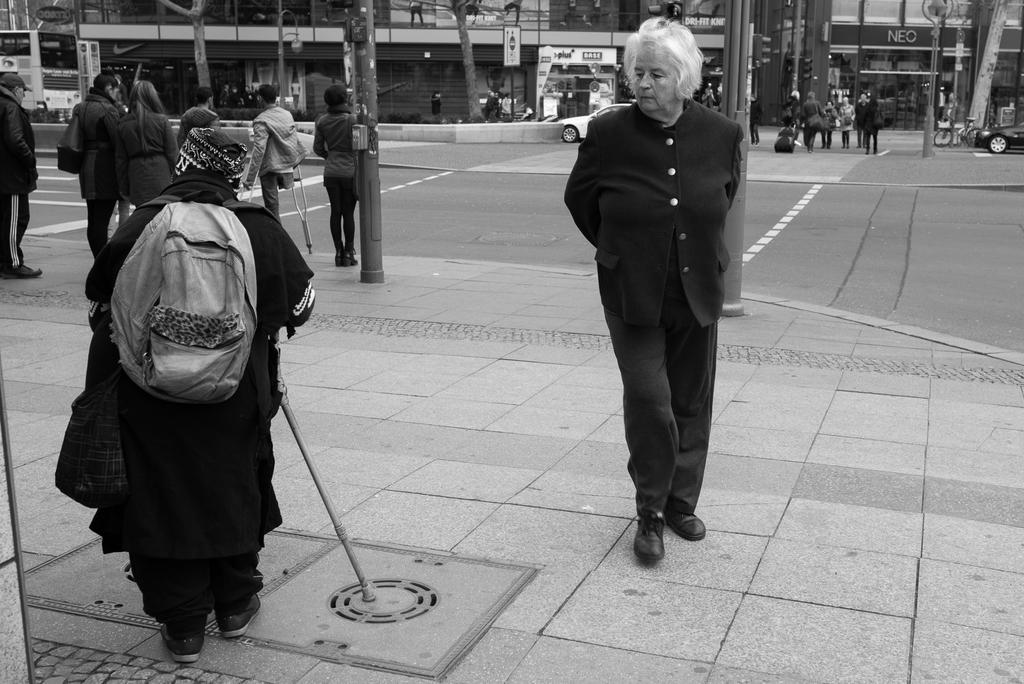What are the persons in the image doing? The persons in the image are walking. What can be seen in the background of the image? In the background of the image, there are poles, persons, cars, buildings, trees, and boards with text. Can you describe the environment in the background of the image? The background of the image features an urban setting with buildings, cars, and people, as well as natural elements like trees and poles. How many muscles can be seen flexing on the face of the person in the image? There is no person's face visible in the image, and therefore no muscles can be seen flexing. 